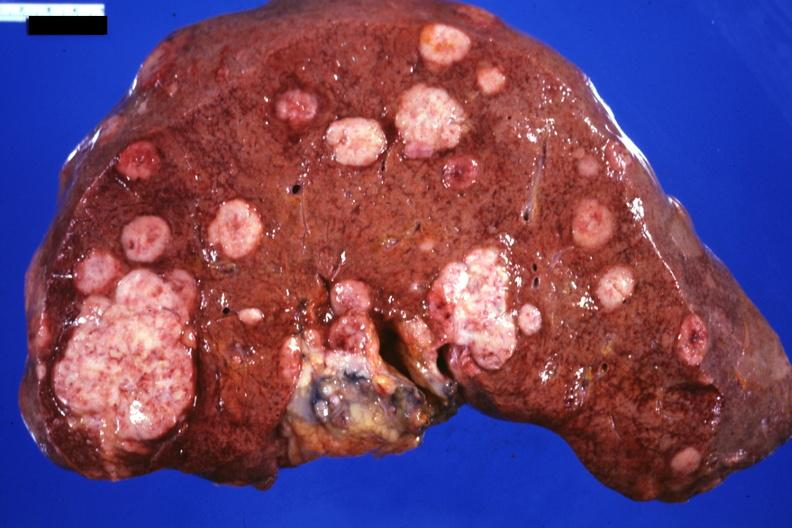s this therapy present?
Answer the question using a single word or phrase. No 